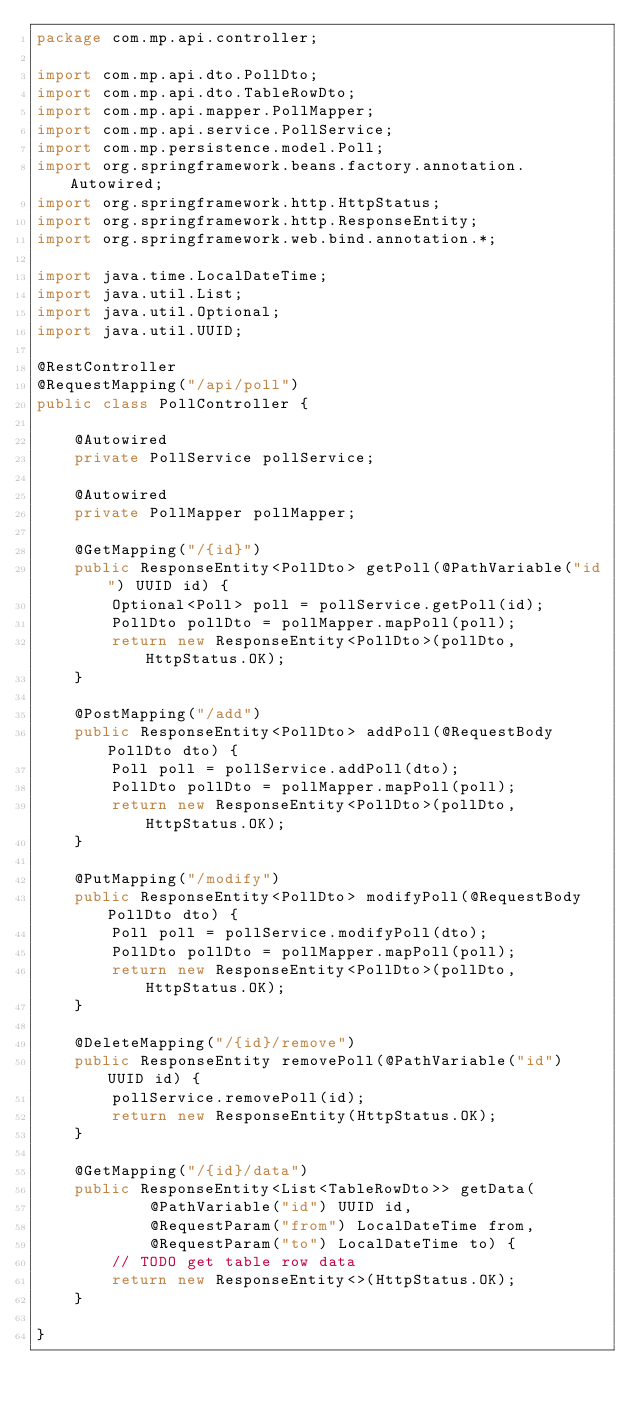<code> <loc_0><loc_0><loc_500><loc_500><_Java_>package com.mp.api.controller;

import com.mp.api.dto.PollDto;
import com.mp.api.dto.TableRowDto;
import com.mp.api.mapper.PollMapper;
import com.mp.api.service.PollService;
import com.mp.persistence.model.Poll;
import org.springframework.beans.factory.annotation.Autowired;
import org.springframework.http.HttpStatus;
import org.springframework.http.ResponseEntity;
import org.springframework.web.bind.annotation.*;

import java.time.LocalDateTime;
import java.util.List;
import java.util.Optional;
import java.util.UUID;

@RestController
@RequestMapping("/api/poll")
public class PollController {

    @Autowired
    private PollService pollService;

    @Autowired
    private PollMapper pollMapper;

    @GetMapping("/{id}")
    public ResponseEntity<PollDto> getPoll(@PathVariable("id") UUID id) {
        Optional<Poll> poll = pollService.getPoll(id);
        PollDto pollDto = pollMapper.mapPoll(poll);
        return new ResponseEntity<PollDto>(pollDto, HttpStatus.OK);
    }

    @PostMapping("/add")
    public ResponseEntity<PollDto> addPoll(@RequestBody PollDto dto) {
        Poll poll = pollService.addPoll(dto);
        PollDto pollDto = pollMapper.mapPoll(poll);
        return new ResponseEntity<PollDto>(pollDto, HttpStatus.OK);
    }

    @PutMapping("/modify")
    public ResponseEntity<PollDto> modifyPoll(@RequestBody PollDto dto) {
        Poll poll = pollService.modifyPoll(dto);
        PollDto pollDto = pollMapper.mapPoll(poll);
        return new ResponseEntity<PollDto>(pollDto, HttpStatus.OK);
    }

    @DeleteMapping("/{id}/remove")
    public ResponseEntity removePoll(@PathVariable("id") UUID id) {
        pollService.removePoll(id);
        return new ResponseEntity(HttpStatus.OK);
    }

    @GetMapping("/{id}/data")
    public ResponseEntity<List<TableRowDto>> getData(
            @PathVariable("id") UUID id,
            @RequestParam("from") LocalDateTime from,
            @RequestParam("to") LocalDateTime to) {
        // TODO get table row data
        return new ResponseEntity<>(HttpStatus.OK);
    }

}
</code> 